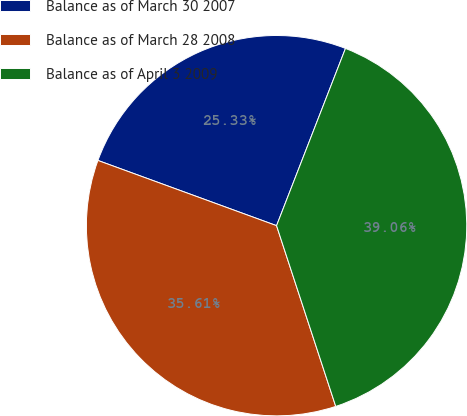<chart> <loc_0><loc_0><loc_500><loc_500><pie_chart><fcel>Balance as of March 30 2007<fcel>Balance as of March 28 2008<fcel>Balance as of April 3 2009<nl><fcel>25.33%<fcel>35.61%<fcel>39.06%<nl></chart> 